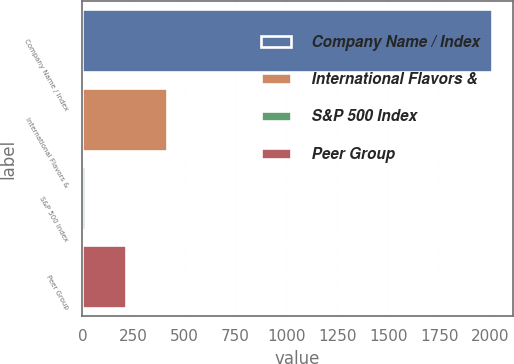<chart> <loc_0><loc_0><loc_500><loc_500><bar_chart><fcel>Company Name / Index<fcel>International Flavors &<fcel>S&P 500 Index<fcel>Peer Group<nl><fcel>2010<fcel>414.04<fcel>15.06<fcel>214.55<nl></chart> 